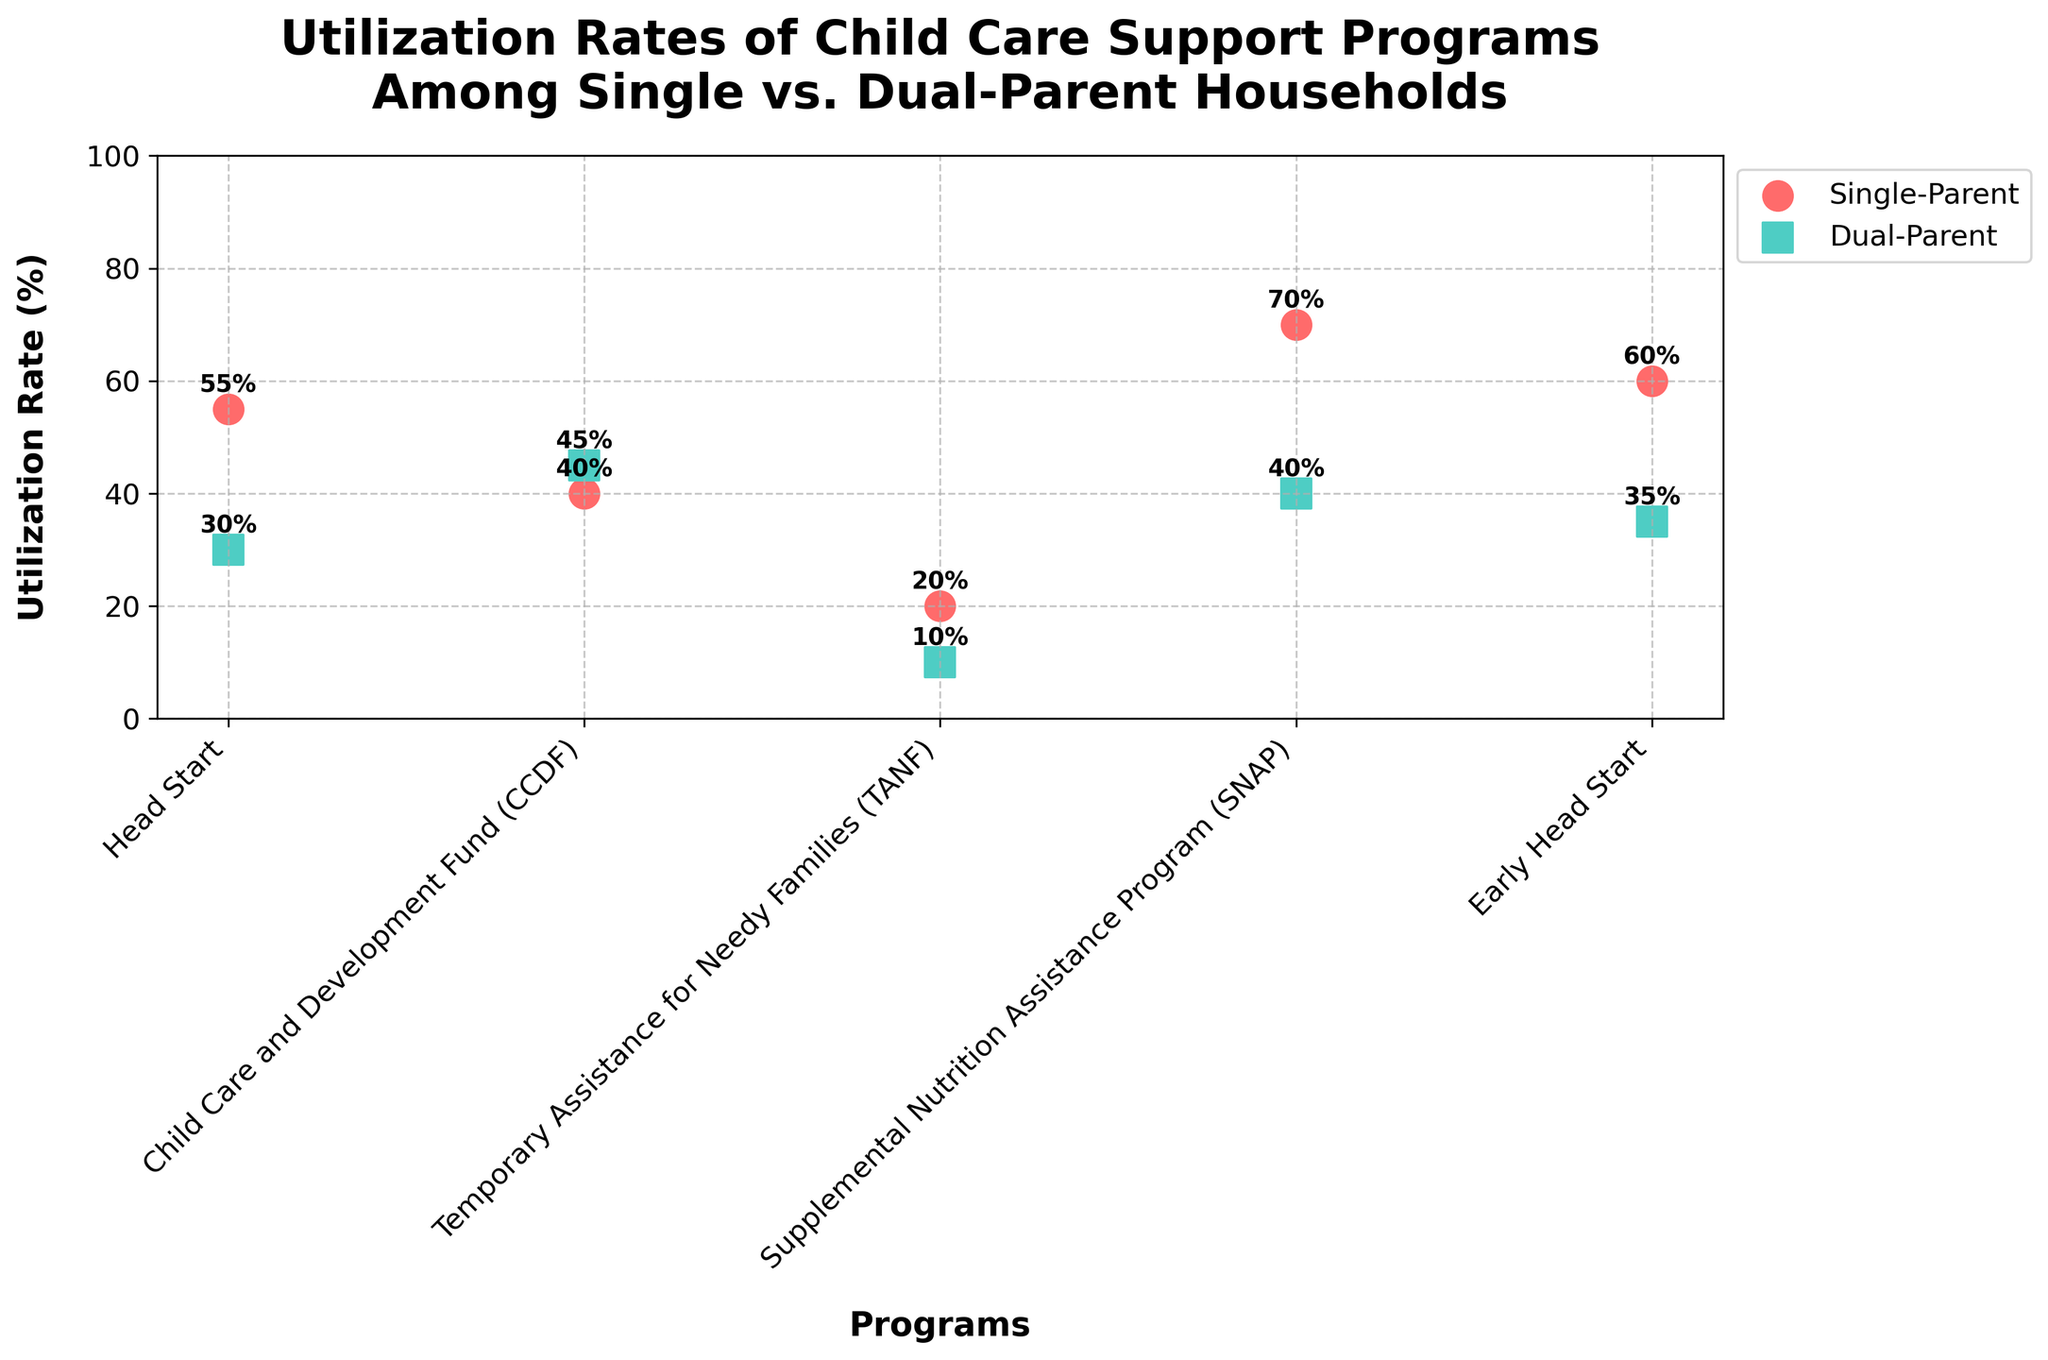what is the title of the plot? The title of the plot is typically found at the top and provides an overview of what the plot represents. The title here is "Utilization Rates of Child Care Support Programs Among Single vs. Dual-Parent Households".
Answer: Utilization Rates of Child Care Support Programs Among Single vs. Dual-Parent Households which household type has a higher utilization rate for the TANF program? We compare the TANF data points for both Single-Parent and Dual-Parent households. The Single-Parent households have a utilization rate of 20%, while Dual-Parent households have a 10% utilization rate. Therefore, Single-Parent households have a higher utilization rate for the TANF program.
Answer: Single-Parent what is the utilization rate of the CCDF program for dual-parent households? The data point for the CCDF program under Dual-Parent households shows a utilization rate of 45%.
Answer: 45% which household type has the highest utilization rate for the Early Head Start program? By comparing the utilization rates for the Early Head Start program, we see that Single-Parent households have a rate of 60%, whereas Dual-Parent households have 35%. Therefore, Single-Parent households have the highest utilization rate for the Early Head Start program.
Answer: Single-Parent how much greater is the utilization rate of the Head Start program among single-parent households compared to dual-parent households? The utilization rate for Head Start under Single-Parent households is 55%, and for Dual-Parent households, it is 30%. The difference can be calculated as 55% - 30% = 25%.
Answer: 25% which child care support program has the lowest utilization rate among single-parent households? We examine the utilization rates for all programs under Single-Parent households. The Temporary Assistance for Needy Families (TANF) program has the lowest rate at 20%.
Answer: Temporary Assistance for Needy Families (TANF) for which program is the difference in utilization rate between single-parent and dual-parent households the smallest? To find the smallest difference, we calculate the differences for each program: 
	Head Start: 55% - 30% = 25% 
	CCDF: 40% - 45% = 5%
	TANF: 20% - 10% = 10% 
	SNAP: 70% - 40% = 30%
	Early Head Start: 60% - 35% = 25%
The CCDF program has the smallest difference, which is 5%.
Answer: Child Care and Development Fund (CCDF) what is the range of the utilization rates for dual-parent households? The range is determined by subtracting the smallest value from the largest value within the Dual-Parent household utilization rates. The largest rate is 45% (CCDF) and the smallest is 10% (TANF), so the range is 45% - 10% = 35%.
Answer: 35% how many data points are plotted for each household type? By counting the number of data points (scatter points) for each household type: Single-Parent households have 5 data points (Head Start, CCDF, TANF, SNAP, Early Head Start) and Dual-Parent households also have 5 data points for the same programs.
Answer: 5 